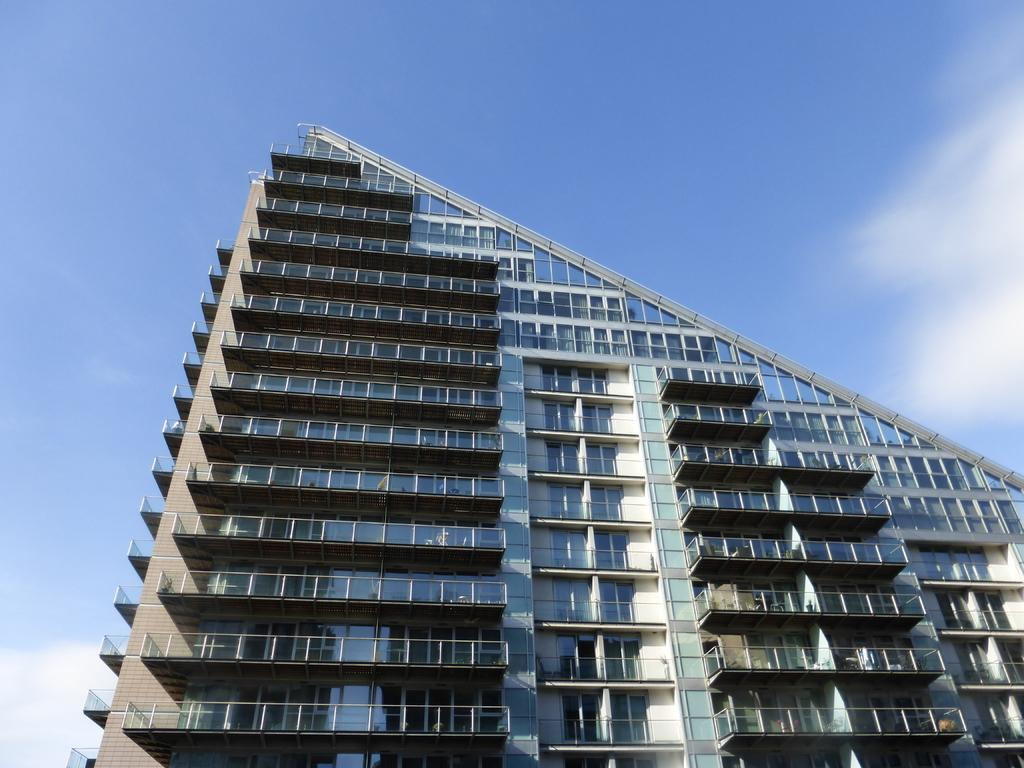What type of structure is present in the image? There is a building in the image. What features can be observed on the building? The building has balconies and windows. What is visible in the background of the image? The sky is visible in the image. What type of company is represented by the building in the image? There is no indication of a specific company in the image; it only shows a building with balconies and windows. What day of the week is depicted in the image? The image does not depict a specific day of the week; it only shows a building and the sky. 